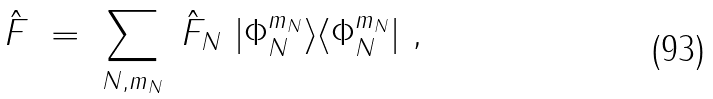<formula> <loc_0><loc_0><loc_500><loc_500>\hat { F } \ = \ \sum _ { N , m _ { N } } \ \hat { F } _ { N } \ | \Phi _ { N } ^ { m _ { N } } \rangle \langle \Phi _ { N } ^ { m _ { N } } | \ ,</formula> 